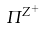<formula> <loc_0><loc_0><loc_500><loc_500>\Pi ^ { Z ^ { + } }</formula> 